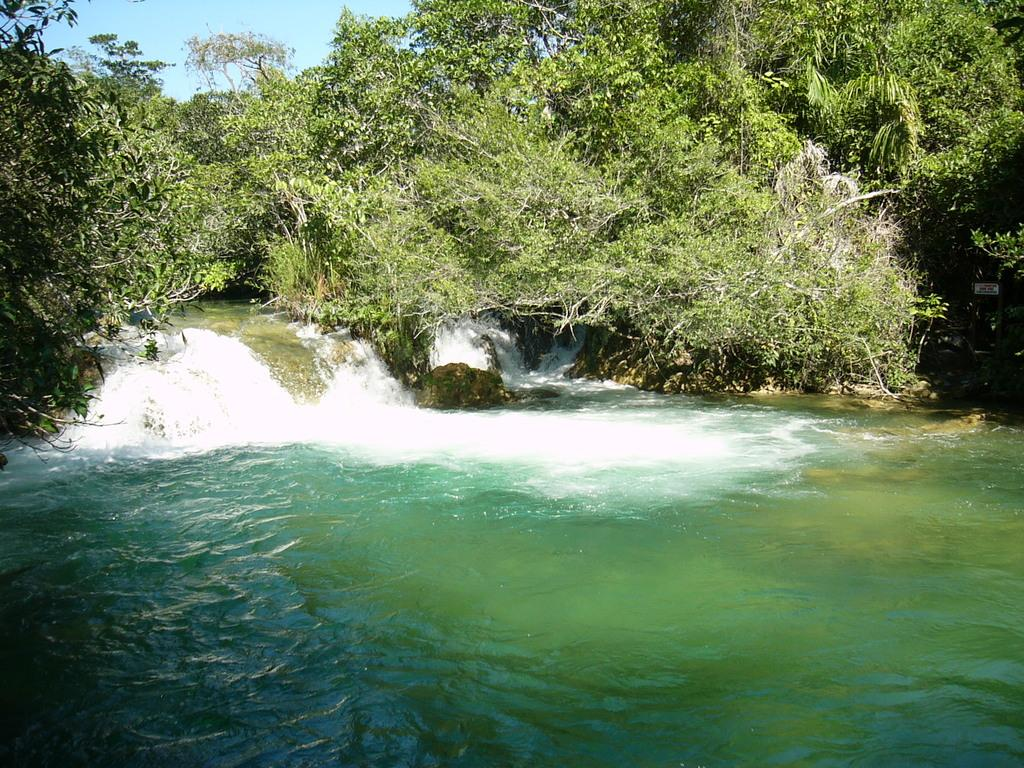What type of vegetation can be seen in the image? There are trees in the image. What natural element is visible in the image besides the trees? There is water visible in the image. What color is the sky in the image? The sky is blue in the image. What type of muscle can be seen flexing in the image? There is no muscle visible in the image; it features trees, water, and a blue sky. 